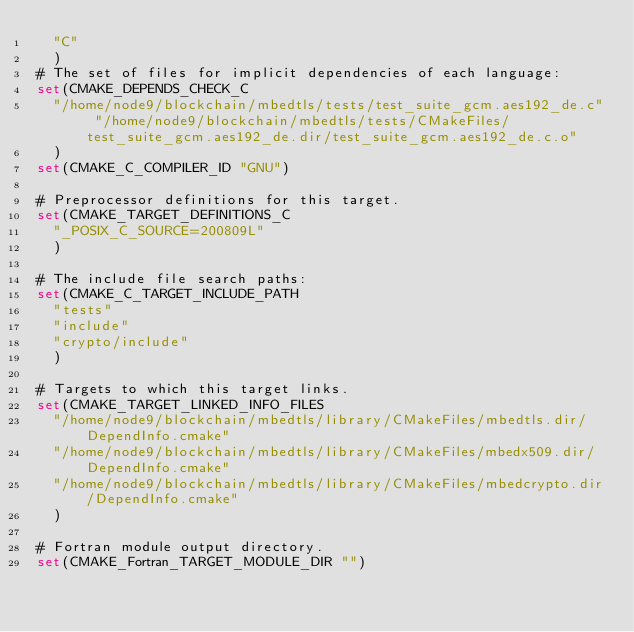<code> <loc_0><loc_0><loc_500><loc_500><_CMake_>  "C"
  )
# The set of files for implicit dependencies of each language:
set(CMAKE_DEPENDS_CHECK_C
  "/home/node9/blockchain/mbedtls/tests/test_suite_gcm.aes192_de.c" "/home/node9/blockchain/mbedtls/tests/CMakeFiles/test_suite_gcm.aes192_de.dir/test_suite_gcm.aes192_de.c.o"
  )
set(CMAKE_C_COMPILER_ID "GNU")

# Preprocessor definitions for this target.
set(CMAKE_TARGET_DEFINITIONS_C
  "_POSIX_C_SOURCE=200809L"
  )

# The include file search paths:
set(CMAKE_C_TARGET_INCLUDE_PATH
  "tests"
  "include"
  "crypto/include"
  )

# Targets to which this target links.
set(CMAKE_TARGET_LINKED_INFO_FILES
  "/home/node9/blockchain/mbedtls/library/CMakeFiles/mbedtls.dir/DependInfo.cmake"
  "/home/node9/blockchain/mbedtls/library/CMakeFiles/mbedx509.dir/DependInfo.cmake"
  "/home/node9/blockchain/mbedtls/library/CMakeFiles/mbedcrypto.dir/DependInfo.cmake"
  )

# Fortran module output directory.
set(CMAKE_Fortran_TARGET_MODULE_DIR "")
</code> 